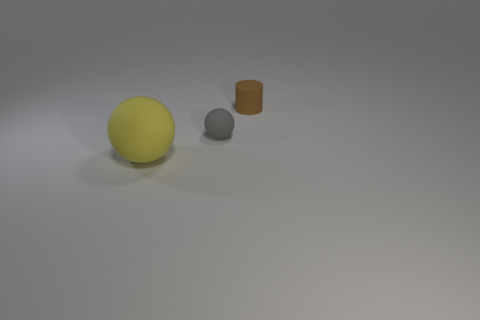Are there any other things that are the same size as the yellow rubber object?
Your response must be concise. No. What number of matte objects are in front of the small gray rubber sphere and behind the yellow sphere?
Offer a very short reply. 0. What number of cylinders are matte things or tiny things?
Offer a very short reply. 1. Are there any red cylinders?
Your answer should be very brief. No. How many other things are made of the same material as the small cylinder?
Your answer should be compact. 2. There is a gray sphere that is the same size as the matte cylinder; what is its material?
Provide a succinct answer. Rubber. There is a small object to the right of the gray sphere; does it have the same shape as the big object?
Provide a short and direct response. No. What number of objects are objects that are left of the small rubber ball or big metallic objects?
Provide a short and direct response. 1. What shape is the brown thing that is the same size as the gray ball?
Give a very brief answer. Cylinder. Do the sphere that is right of the big yellow object and the sphere that is left of the small gray matte object have the same size?
Offer a terse response. No. 